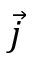Convert formula to latex. <formula><loc_0><loc_0><loc_500><loc_500>\vec { j }</formula> 